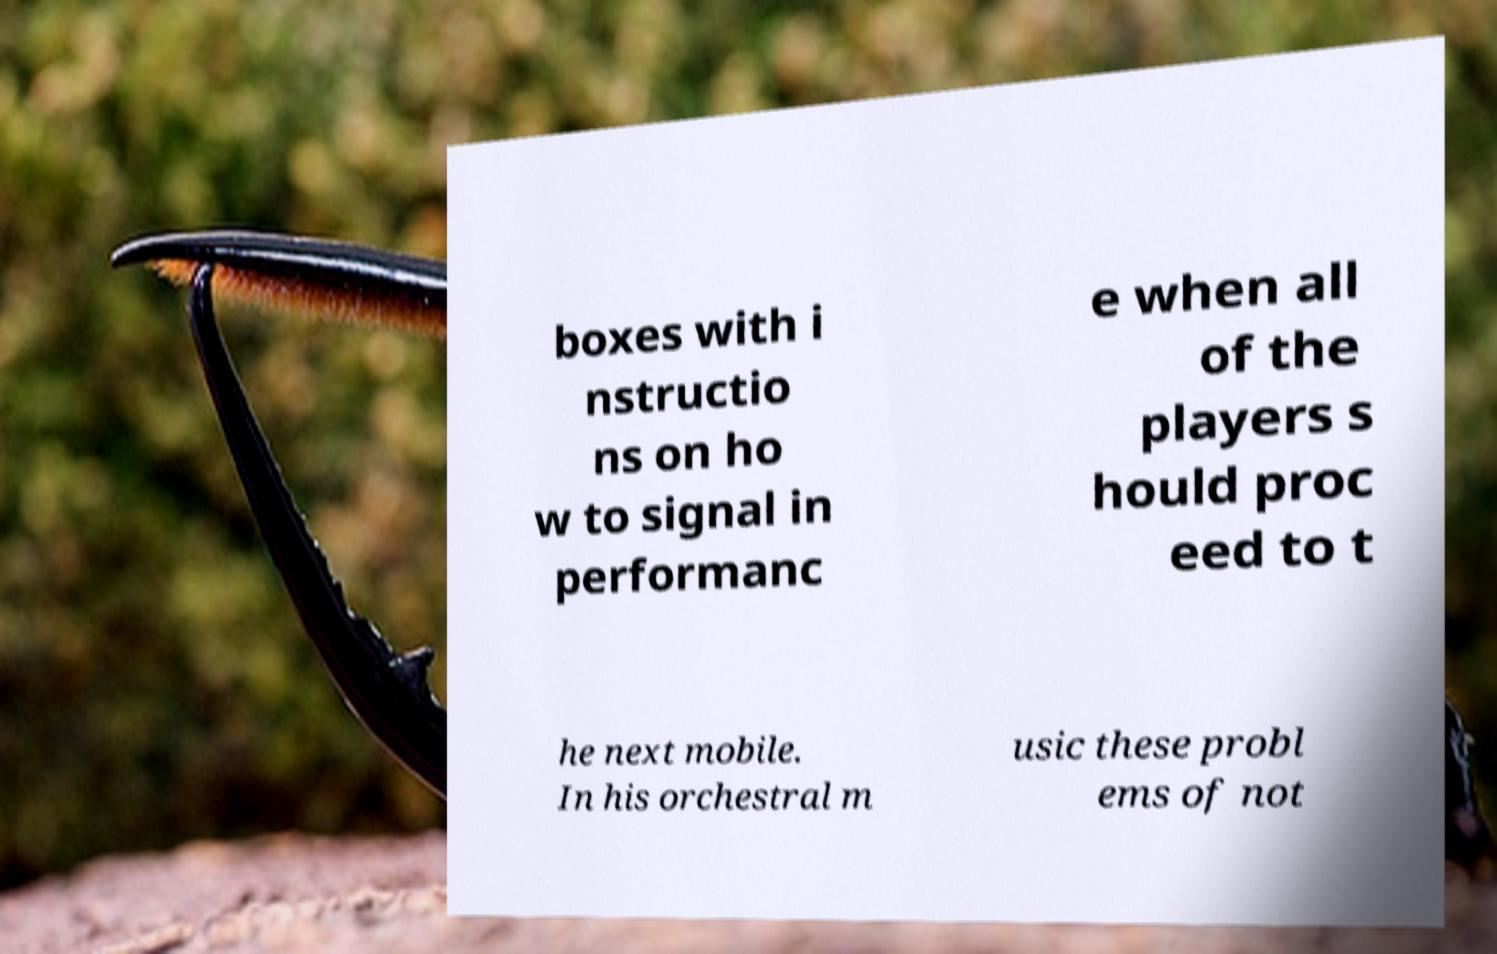There's text embedded in this image that I need extracted. Can you transcribe it verbatim? boxes with i nstructio ns on ho w to signal in performanc e when all of the players s hould proc eed to t he next mobile. In his orchestral m usic these probl ems of not 